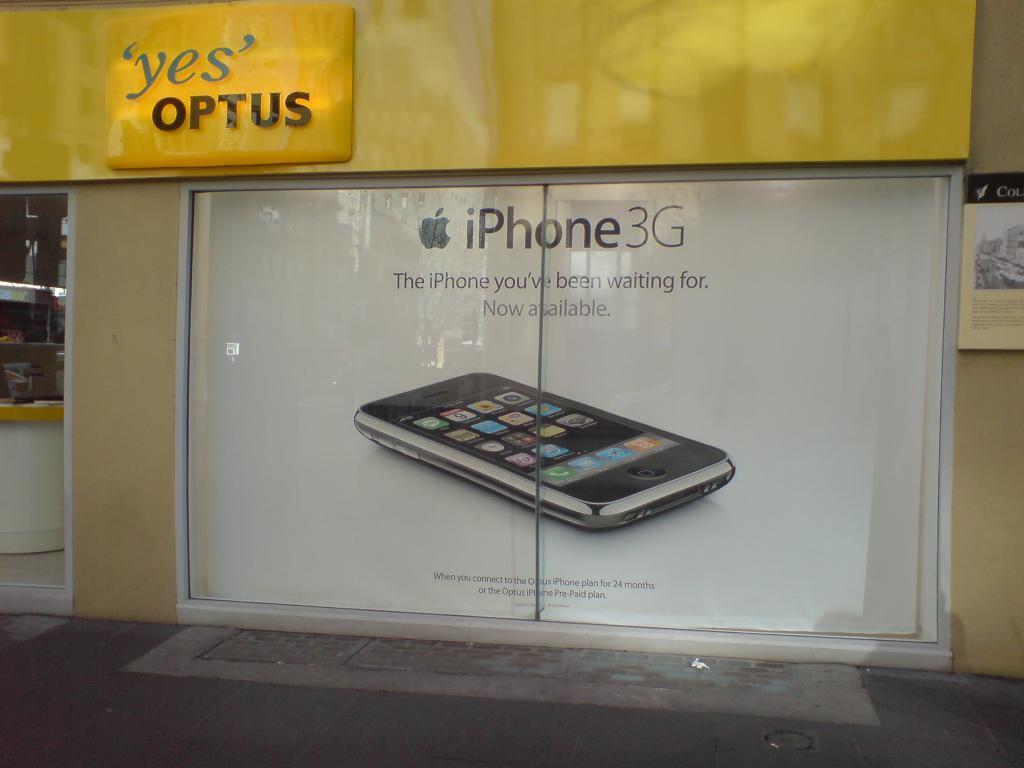Could you give a brief overview of what you see in this image? In this picture we can observe an iPhone on the white color background. We can observe some text on the door. We can observe yellow color board. 